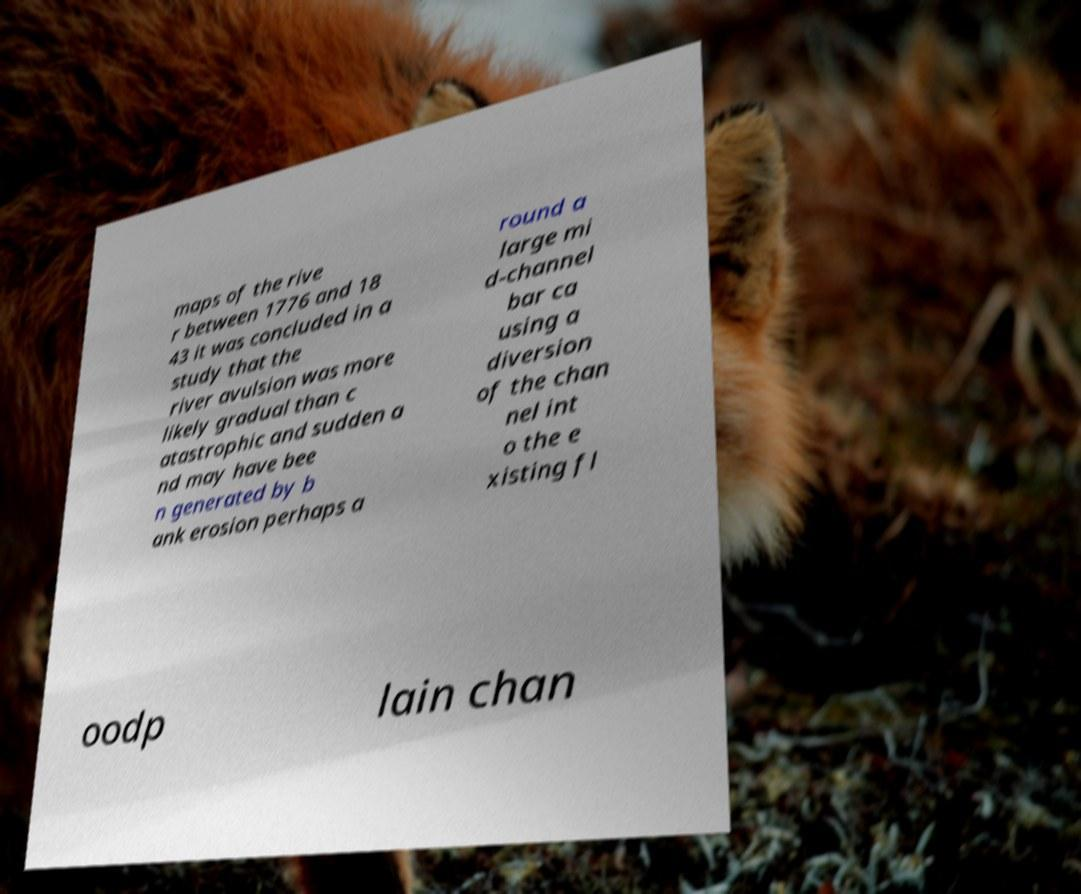There's text embedded in this image that I need extracted. Can you transcribe it verbatim? maps of the rive r between 1776 and 18 43 it was concluded in a study that the river avulsion was more likely gradual than c atastrophic and sudden a nd may have bee n generated by b ank erosion perhaps a round a large mi d-channel bar ca using a diversion of the chan nel int o the e xisting fl oodp lain chan 